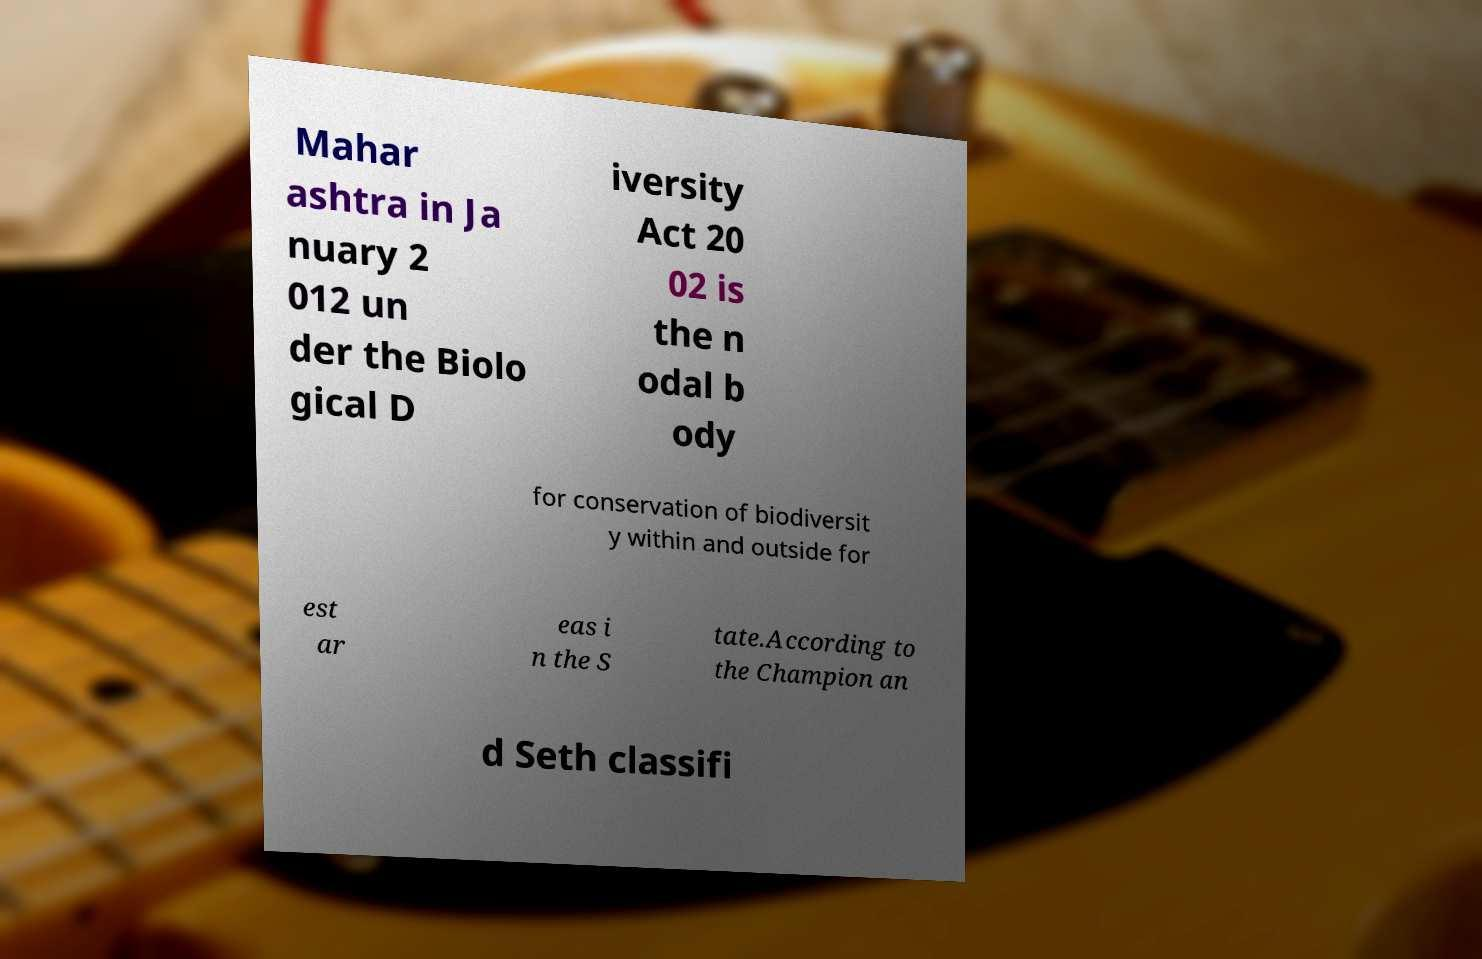Please identify and transcribe the text found in this image. Mahar ashtra in Ja nuary 2 012 un der the Biolo gical D iversity Act 20 02 is the n odal b ody for conservation of biodiversit y within and outside for est ar eas i n the S tate.According to the Champion an d Seth classifi 